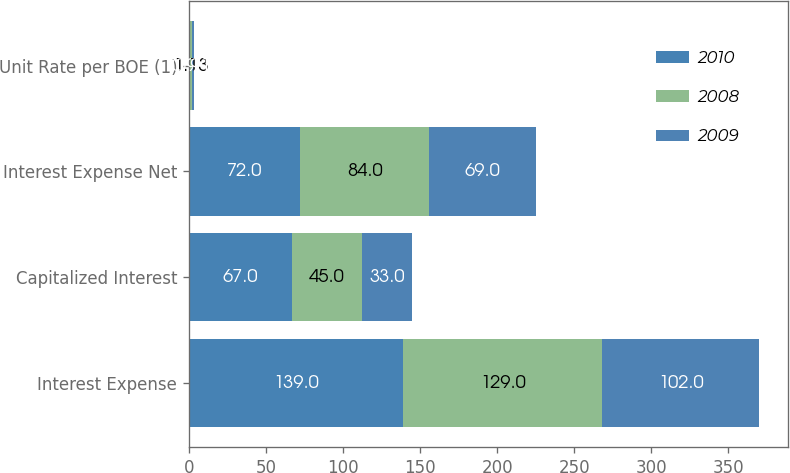<chart> <loc_0><loc_0><loc_500><loc_500><stacked_bar_chart><ecel><fcel>Interest Expense<fcel>Capitalized Interest<fcel>Interest Expense Net<fcel>Unit Rate per BOE (1)<nl><fcel>2010<fcel>139<fcel>67<fcel>72<fcel>0.94<nl><fcel>2008<fcel>129<fcel>45<fcel>84<fcel>1.13<nl><fcel>2009<fcel>102<fcel>33<fcel>69<fcel>0.91<nl></chart> 